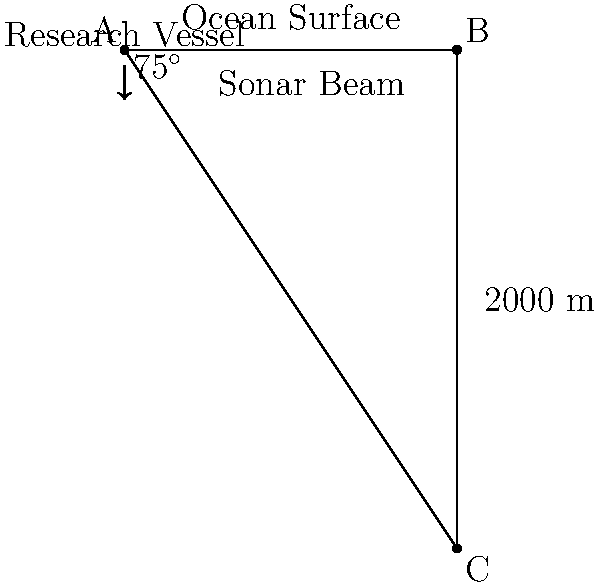During a research expedition, your team is investigating a newly discovered hydrothermal vent field. Your research vessel's sonar system emits a beam at an angle of 75° from the vertical. The sonar detects the hydrothermal vent at a distance of 2000 meters along the beam path. Calculate the depth of the hydrothermal vent below the ocean surface. To solve this problem, we'll use trigonometric ratios in a right-angled triangle. Let's approach this step-by-step:

1) First, let's identify the known variables:
   - The angle of the sonar beam from the vertical is 75°
   - The distance along the beam (hypotenuse of the triangle) is 2000 m

2) We need to find the depth, which is the opposite side to the 15° angle (90° - 75° = 15°) in the right-angled triangle.

3) We can use the sine ratio to find the depth:

   $$\sin(15°) = \frac{\text{opposite}}{\text{hypotenuse}} = \frac{\text{depth}}{2000}$$

4) Rearranging the equation:

   $$\text{depth} = 2000 \times \sin(15°)$$

5) Now, let's calculate:
   
   $$\text{depth} = 2000 \times \sin(15°)$$
   $$\text{depth} = 2000 \times 0.2588$$
   $$\text{depth} = 517.6 \text{ meters}$$

6) Rounding to the nearest meter:
   
   $$\text{depth} \approx 518 \text{ meters}$$

Therefore, the hydrothermal vent is approximately 518 meters below the ocean surface.
Answer: 518 meters 